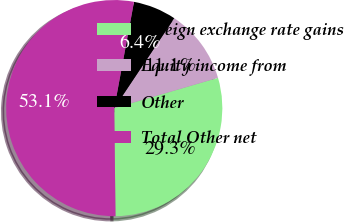Convert chart to OTSL. <chart><loc_0><loc_0><loc_500><loc_500><pie_chart><fcel>Foreign exchange rate gains<fcel>Equity income from<fcel>Other<fcel>Total Other net<nl><fcel>29.34%<fcel>11.11%<fcel>6.44%<fcel>53.12%<nl></chart> 